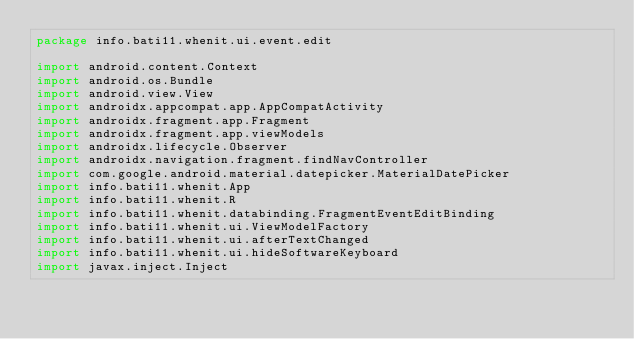<code> <loc_0><loc_0><loc_500><loc_500><_Kotlin_>package info.bati11.whenit.ui.event.edit

import android.content.Context
import android.os.Bundle
import android.view.View
import androidx.appcompat.app.AppCompatActivity
import androidx.fragment.app.Fragment
import androidx.fragment.app.viewModels
import androidx.lifecycle.Observer
import androidx.navigation.fragment.findNavController
import com.google.android.material.datepicker.MaterialDatePicker
import info.bati11.whenit.App
import info.bati11.whenit.R
import info.bati11.whenit.databinding.FragmentEventEditBinding
import info.bati11.whenit.ui.ViewModelFactory
import info.bati11.whenit.ui.afterTextChanged
import info.bati11.whenit.ui.hideSoftwareKeyboard
import javax.inject.Inject
</code> 